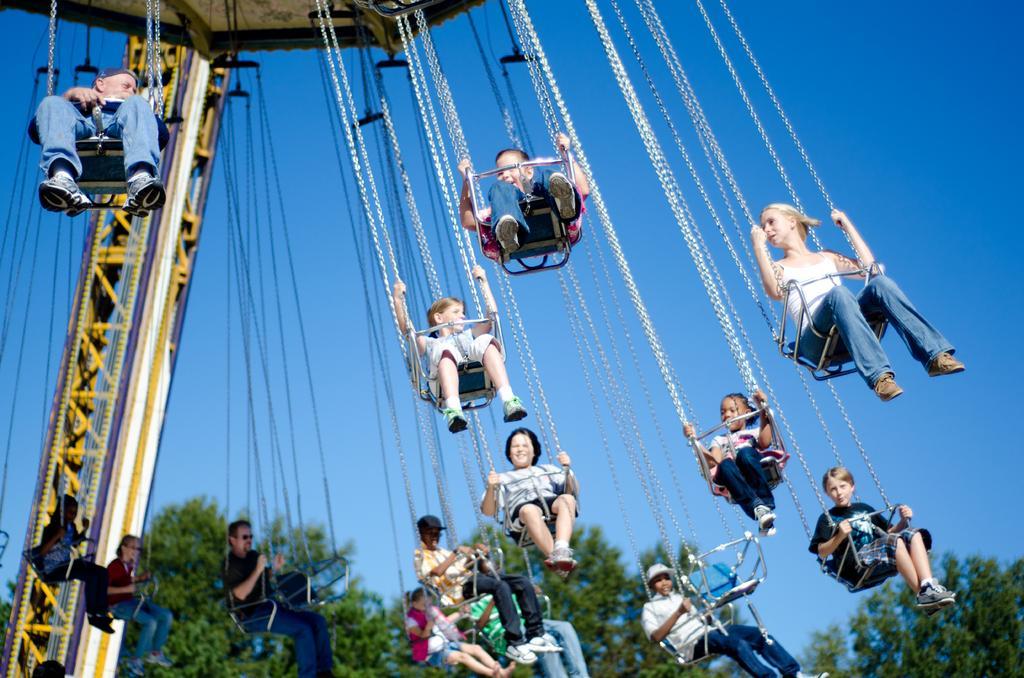How would you summarize this image in a sentence or two? In this image we can see people are present on the chain swing ride. In the background, we can see the sky and trees. 